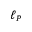<formula> <loc_0><loc_0><loc_500><loc_500>\ell _ { P }</formula> 